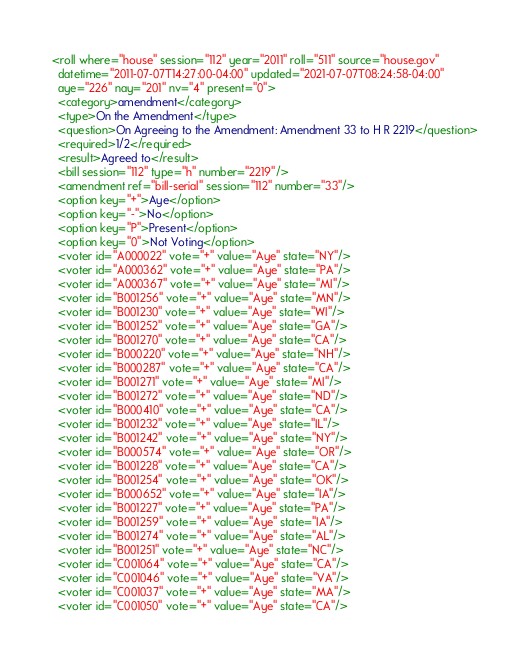<code> <loc_0><loc_0><loc_500><loc_500><_XML_><roll where="house" session="112" year="2011" roll="511" source="house.gov"
  datetime="2011-07-07T14:27:00-04:00" updated="2021-07-07T08:24:58-04:00"
  aye="226" nay="201" nv="4" present="0">
  <category>amendment</category>
  <type>On the Amendment</type>
  <question>On Agreeing to the Amendment: Amendment 33 to H R 2219</question>
  <required>1/2</required>
  <result>Agreed to</result>
  <bill session="112" type="h" number="2219"/>
  <amendment ref="bill-serial" session="112" number="33"/>
  <option key="+">Aye</option>
  <option key="-">No</option>
  <option key="P">Present</option>
  <option key="0">Not Voting</option>
  <voter id="A000022" vote="+" value="Aye" state="NY"/>
  <voter id="A000362" vote="+" value="Aye" state="PA"/>
  <voter id="A000367" vote="+" value="Aye" state="MI"/>
  <voter id="B001256" vote="+" value="Aye" state="MN"/>
  <voter id="B001230" vote="+" value="Aye" state="WI"/>
  <voter id="B001252" vote="+" value="Aye" state="GA"/>
  <voter id="B001270" vote="+" value="Aye" state="CA"/>
  <voter id="B000220" vote="+" value="Aye" state="NH"/>
  <voter id="B000287" vote="+" value="Aye" state="CA"/>
  <voter id="B001271" vote="+" value="Aye" state="MI"/>
  <voter id="B001272" vote="+" value="Aye" state="ND"/>
  <voter id="B000410" vote="+" value="Aye" state="CA"/>
  <voter id="B001232" vote="+" value="Aye" state="IL"/>
  <voter id="B001242" vote="+" value="Aye" state="NY"/>
  <voter id="B000574" vote="+" value="Aye" state="OR"/>
  <voter id="B001228" vote="+" value="Aye" state="CA"/>
  <voter id="B001254" vote="+" value="Aye" state="OK"/>
  <voter id="B000652" vote="+" value="Aye" state="IA"/>
  <voter id="B001227" vote="+" value="Aye" state="PA"/>
  <voter id="B001259" vote="+" value="Aye" state="IA"/>
  <voter id="B001274" vote="+" value="Aye" state="AL"/>
  <voter id="B001251" vote="+" value="Aye" state="NC"/>
  <voter id="C001064" vote="+" value="Aye" state="CA"/>
  <voter id="C001046" vote="+" value="Aye" state="VA"/>
  <voter id="C001037" vote="+" value="Aye" state="MA"/>
  <voter id="C001050" vote="+" value="Aye" state="CA"/></code> 